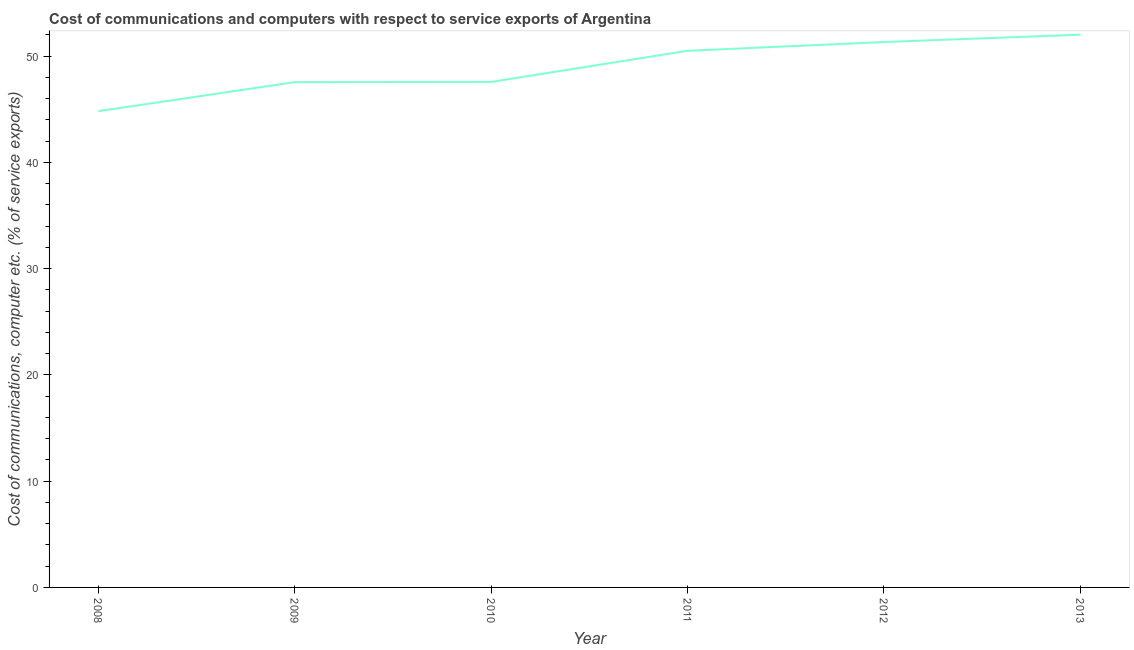What is the cost of communications and computer in 2012?
Offer a terse response. 51.33. Across all years, what is the maximum cost of communications and computer?
Your answer should be compact. 52.03. Across all years, what is the minimum cost of communications and computer?
Keep it short and to the point. 44.83. In which year was the cost of communications and computer maximum?
Your answer should be very brief. 2013. What is the sum of the cost of communications and computer?
Your answer should be very brief. 293.83. What is the difference between the cost of communications and computer in 2009 and 2013?
Give a very brief answer. -4.47. What is the average cost of communications and computer per year?
Ensure brevity in your answer.  48.97. What is the median cost of communications and computer?
Your answer should be compact. 49.04. Do a majority of the years between 2013 and 2012 (inclusive) have cost of communications and computer greater than 10 %?
Keep it short and to the point. No. What is the ratio of the cost of communications and computer in 2012 to that in 2013?
Ensure brevity in your answer.  0.99. Is the cost of communications and computer in 2008 less than that in 2009?
Offer a terse response. Yes. Is the difference between the cost of communications and computer in 2008 and 2010 greater than the difference between any two years?
Provide a succinct answer. No. What is the difference between the highest and the second highest cost of communications and computer?
Keep it short and to the point. 0.7. Is the sum of the cost of communications and computer in 2008 and 2012 greater than the maximum cost of communications and computer across all years?
Offer a very short reply. Yes. What is the difference between the highest and the lowest cost of communications and computer?
Offer a terse response. 7.2. Does the cost of communications and computer monotonically increase over the years?
Your answer should be very brief. Yes. How many lines are there?
Provide a succinct answer. 1. How many years are there in the graph?
Keep it short and to the point. 6. What is the difference between two consecutive major ticks on the Y-axis?
Give a very brief answer. 10. Are the values on the major ticks of Y-axis written in scientific E-notation?
Offer a terse response. No. Does the graph contain any zero values?
Your response must be concise. No. What is the title of the graph?
Keep it short and to the point. Cost of communications and computers with respect to service exports of Argentina. What is the label or title of the Y-axis?
Offer a very short reply. Cost of communications, computer etc. (% of service exports). What is the Cost of communications, computer etc. (% of service exports) of 2008?
Give a very brief answer. 44.83. What is the Cost of communications, computer etc. (% of service exports) in 2009?
Your answer should be very brief. 47.56. What is the Cost of communications, computer etc. (% of service exports) of 2010?
Offer a very short reply. 47.58. What is the Cost of communications, computer etc. (% of service exports) in 2011?
Make the answer very short. 50.51. What is the Cost of communications, computer etc. (% of service exports) of 2012?
Provide a short and direct response. 51.33. What is the Cost of communications, computer etc. (% of service exports) of 2013?
Give a very brief answer. 52.03. What is the difference between the Cost of communications, computer etc. (% of service exports) in 2008 and 2009?
Keep it short and to the point. -2.73. What is the difference between the Cost of communications, computer etc. (% of service exports) in 2008 and 2010?
Give a very brief answer. -2.75. What is the difference between the Cost of communications, computer etc. (% of service exports) in 2008 and 2011?
Provide a short and direct response. -5.68. What is the difference between the Cost of communications, computer etc. (% of service exports) in 2008 and 2012?
Offer a terse response. -6.51. What is the difference between the Cost of communications, computer etc. (% of service exports) in 2008 and 2013?
Your response must be concise. -7.2. What is the difference between the Cost of communications, computer etc. (% of service exports) in 2009 and 2010?
Provide a succinct answer. -0.02. What is the difference between the Cost of communications, computer etc. (% of service exports) in 2009 and 2011?
Provide a short and direct response. -2.95. What is the difference between the Cost of communications, computer etc. (% of service exports) in 2009 and 2012?
Make the answer very short. -3.77. What is the difference between the Cost of communications, computer etc. (% of service exports) in 2009 and 2013?
Ensure brevity in your answer.  -4.47. What is the difference between the Cost of communications, computer etc. (% of service exports) in 2010 and 2011?
Offer a terse response. -2.93. What is the difference between the Cost of communications, computer etc. (% of service exports) in 2010 and 2012?
Provide a short and direct response. -3.75. What is the difference between the Cost of communications, computer etc. (% of service exports) in 2010 and 2013?
Your answer should be very brief. -4.45. What is the difference between the Cost of communications, computer etc. (% of service exports) in 2011 and 2012?
Your answer should be very brief. -0.82. What is the difference between the Cost of communications, computer etc. (% of service exports) in 2011 and 2013?
Offer a terse response. -1.52. What is the difference between the Cost of communications, computer etc. (% of service exports) in 2012 and 2013?
Give a very brief answer. -0.7. What is the ratio of the Cost of communications, computer etc. (% of service exports) in 2008 to that in 2009?
Make the answer very short. 0.94. What is the ratio of the Cost of communications, computer etc. (% of service exports) in 2008 to that in 2010?
Provide a succinct answer. 0.94. What is the ratio of the Cost of communications, computer etc. (% of service exports) in 2008 to that in 2011?
Provide a short and direct response. 0.89. What is the ratio of the Cost of communications, computer etc. (% of service exports) in 2008 to that in 2012?
Ensure brevity in your answer.  0.87. What is the ratio of the Cost of communications, computer etc. (% of service exports) in 2008 to that in 2013?
Offer a terse response. 0.86. What is the ratio of the Cost of communications, computer etc. (% of service exports) in 2009 to that in 2010?
Your response must be concise. 1. What is the ratio of the Cost of communications, computer etc. (% of service exports) in 2009 to that in 2011?
Provide a succinct answer. 0.94. What is the ratio of the Cost of communications, computer etc. (% of service exports) in 2009 to that in 2012?
Your answer should be very brief. 0.93. What is the ratio of the Cost of communications, computer etc. (% of service exports) in 2009 to that in 2013?
Keep it short and to the point. 0.91. What is the ratio of the Cost of communications, computer etc. (% of service exports) in 2010 to that in 2011?
Provide a succinct answer. 0.94. What is the ratio of the Cost of communications, computer etc. (% of service exports) in 2010 to that in 2012?
Ensure brevity in your answer.  0.93. What is the ratio of the Cost of communications, computer etc. (% of service exports) in 2010 to that in 2013?
Offer a very short reply. 0.91. What is the ratio of the Cost of communications, computer etc. (% of service exports) in 2011 to that in 2012?
Offer a very short reply. 0.98. What is the ratio of the Cost of communications, computer etc. (% of service exports) in 2011 to that in 2013?
Give a very brief answer. 0.97. 